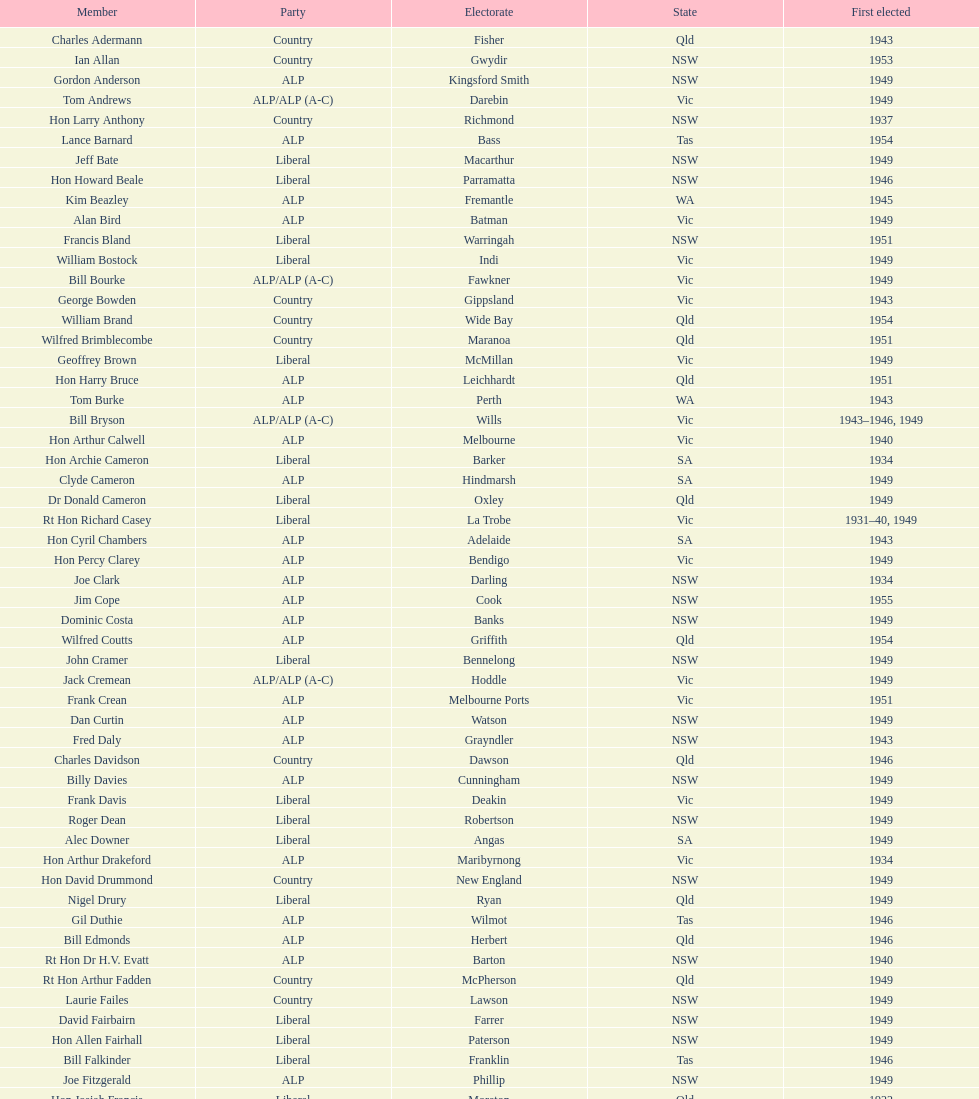Previous to tom andrews who was elected? Gordon Anderson. 